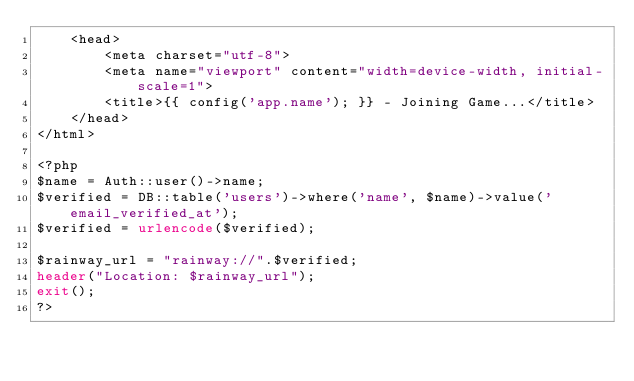Convert code to text. <code><loc_0><loc_0><loc_500><loc_500><_PHP_>    <head>
        <meta charset="utf-8">
        <meta name="viewport" content="width=device-width, initial-scale=1">
        <title>{{ config('app.name'); }} - Joining Game...</title>
    </head>
</html>

<?php 
$name = Auth::user()->name;
$verified = DB::table('users')->where('name', $name)->value('email_verified_at');
$verified = urlencode($verified);

$rainway_url = "rainway://".$verified;
header("Location: $rainway_url");
exit();
?></code> 